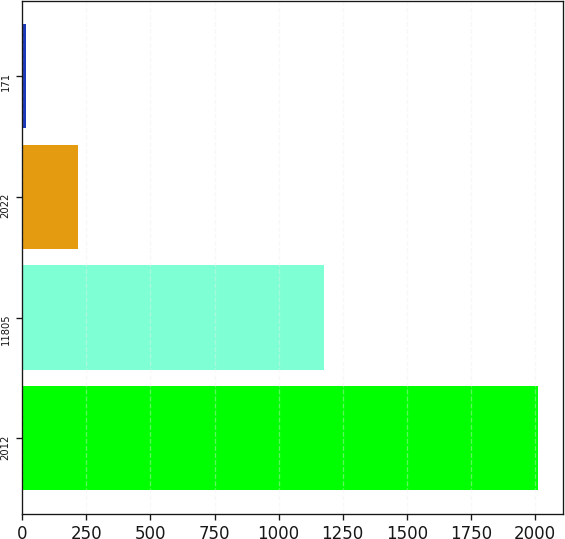<chart> <loc_0><loc_0><loc_500><loc_500><bar_chart><fcel>2012<fcel>11805<fcel>2022<fcel>171<nl><fcel>2011<fcel>1177.6<fcel>215.41<fcel>15.9<nl></chart> 